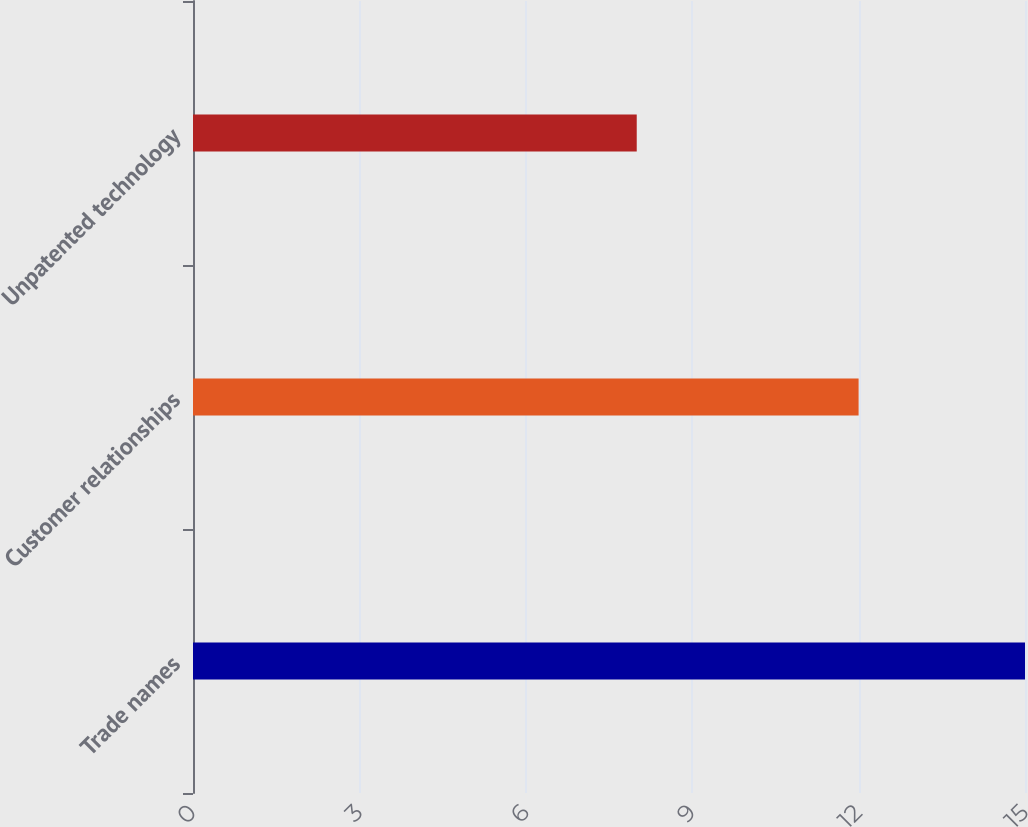<chart> <loc_0><loc_0><loc_500><loc_500><bar_chart><fcel>Trade names<fcel>Customer relationships<fcel>Unpatented technology<nl><fcel>15<fcel>12<fcel>8<nl></chart> 